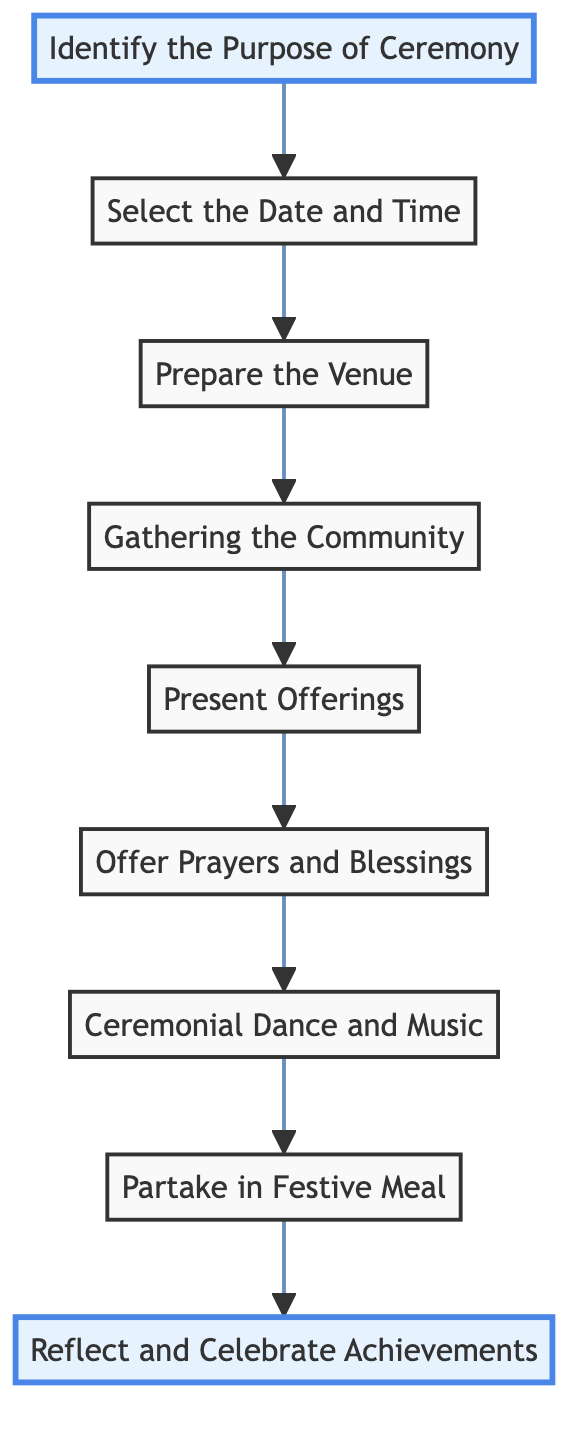What is the first step in organizing a Sherpa cultural ceremony? The first step indicated in the diagram is "Identify the Purpose of Ceremony," which is located at the bottom of the flow chart. This step sets the foundation for all subsequent actions in the process.
Answer: Identify the Purpose of Ceremony How many total steps are involved in the ceremony organization? By counting the nodes from the bottom to the top of the flow chart, there are 9 steps included in the organization of a Sherpa cultural ceremony.
Answer: 9 What follows after "Gathering the Community"? The flow chart shows that after "Gathering the Community," the next step is "Present Offerings." This demonstrates the sequential nature of the ceremony planning process.
Answer: Present Offerings Which step incorporates traditional Sherpa dances and songs? According to the flow chart, "Ceremonial Dance and Music" is the step that includes engaging in traditional dances and songs, highlighting cultural expression within the ceremony.
Answer: Ceremonial Dance and Music What is the last step in the flow chart? The final step in the diagram is "Reflect and Celebrate Achievements," indicating the conclusion of the ceremony where blessings are offered.
Answer: Reflect and Celebrate Achievements Which step involves preparing the physical space for the ceremony? The step that involves preparing the venue is labeled "Prepare the Venue," which outlines the necessity of decorating and organizing the space for the gathering.
Answer: Prepare the Venue What is the sequence of events after selecting the date and time? The sequence after selecting the date and time starts with "Prepare the Venue," then progresses to "Gathering the Community," indicating that these steps occur in that order following the selection.
Answer: Prepare the Venue, Gathering the Community How does the ceremony begin? The diagram indicates that the ceremony begins with "Identify the Purpose of Ceremony," which lays out the intention and context before any subsequent actions are taken.
Answer: Identify the Purpose of Ceremony 